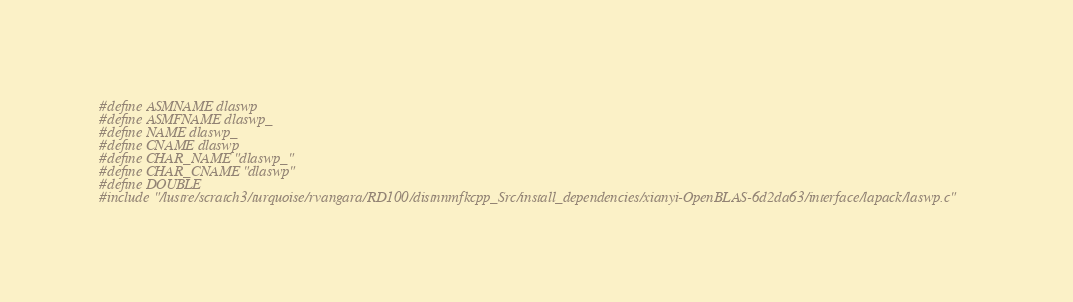Convert code to text. <code><loc_0><loc_0><loc_500><loc_500><_C_>#define ASMNAME dlaswp
#define ASMFNAME dlaswp_
#define NAME dlaswp_
#define CNAME dlaswp
#define CHAR_NAME "dlaswp_"
#define CHAR_CNAME "dlaswp"
#define DOUBLE
#include "/lustre/scratch3/turquoise/rvangara/RD100/distnnmfkcpp_Src/install_dependencies/xianyi-OpenBLAS-6d2da63/interface/lapack/laswp.c"</code> 